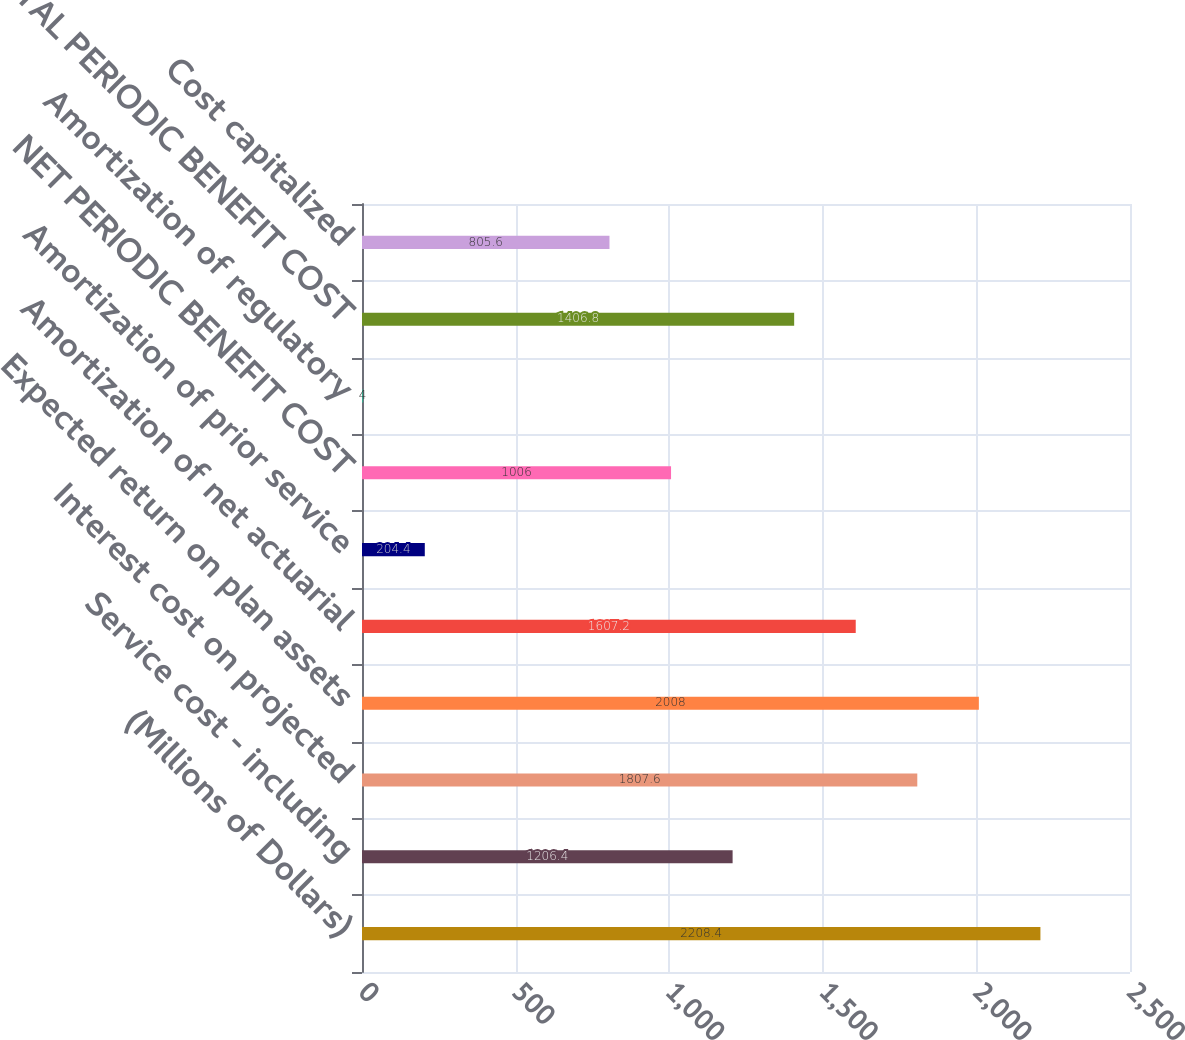<chart> <loc_0><loc_0><loc_500><loc_500><bar_chart><fcel>(Millions of Dollars)<fcel>Service cost - including<fcel>Interest cost on projected<fcel>Expected return on plan assets<fcel>Amortization of net actuarial<fcel>Amortization of prior service<fcel>NET PERIODIC BENEFIT COST<fcel>Amortization of regulatory<fcel>TOTAL PERIODIC BENEFIT COST<fcel>Cost capitalized<nl><fcel>2208.4<fcel>1206.4<fcel>1807.6<fcel>2008<fcel>1607.2<fcel>204.4<fcel>1006<fcel>4<fcel>1406.8<fcel>805.6<nl></chart> 